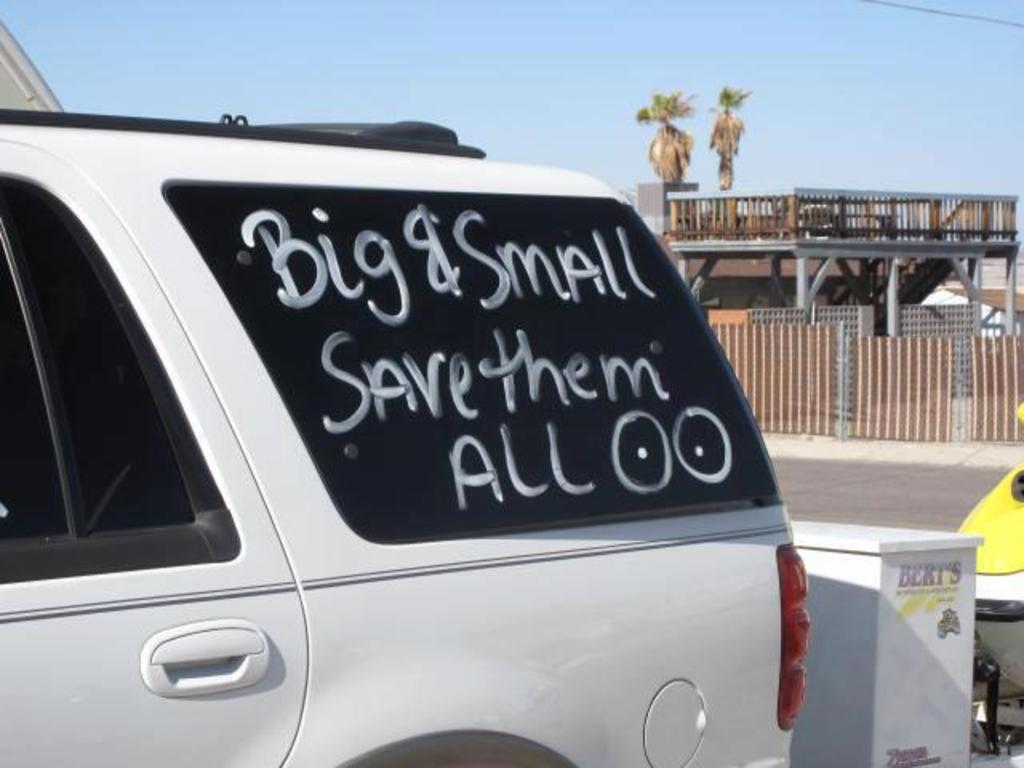What is the main subject of the image? There is a car in the center of the image. Where is the car located? The car is on the road. What can be seen in the background of the image? There are trees, a road, fencing, wooden stairs, and the sky visible in the background of the image. What type of clouds can be seen in the image? There are no clouds visible in the image; the sky is visible, but no clouds are mentioned in the provided facts. 